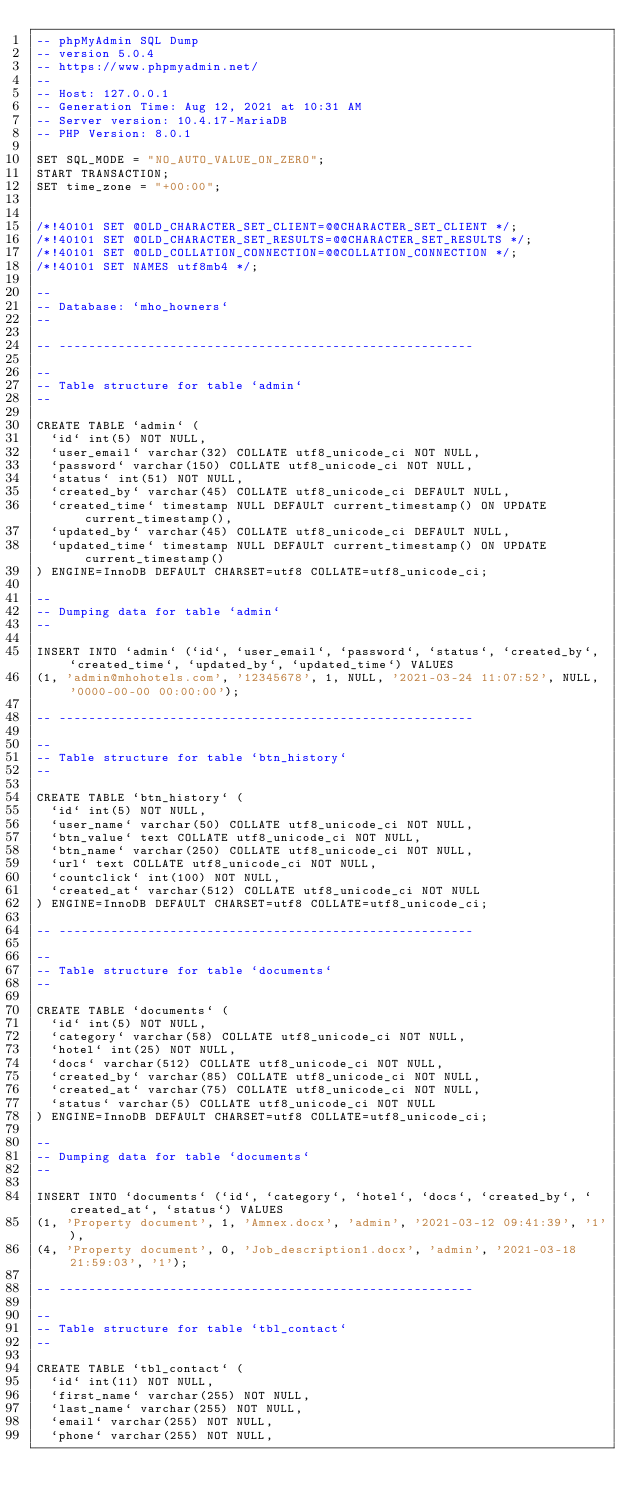Convert code to text. <code><loc_0><loc_0><loc_500><loc_500><_SQL_>-- phpMyAdmin SQL Dump
-- version 5.0.4
-- https://www.phpmyadmin.net/
--
-- Host: 127.0.0.1
-- Generation Time: Aug 12, 2021 at 10:31 AM
-- Server version: 10.4.17-MariaDB
-- PHP Version: 8.0.1

SET SQL_MODE = "NO_AUTO_VALUE_ON_ZERO";
START TRANSACTION;
SET time_zone = "+00:00";


/*!40101 SET @OLD_CHARACTER_SET_CLIENT=@@CHARACTER_SET_CLIENT */;
/*!40101 SET @OLD_CHARACTER_SET_RESULTS=@@CHARACTER_SET_RESULTS */;
/*!40101 SET @OLD_COLLATION_CONNECTION=@@COLLATION_CONNECTION */;
/*!40101 SET NAMES utf8mb4 */;

--
-- Database: `mho_howners`
--

-- --------------------------------------------------------

--
-- Table structure for table `admin`
--

CREATE TABLE `admin` (
  `id` int(5) NOT NULL,
  `user_email` varchar(32) COLLATE utf8_unicode_ci NOT NULL,
  `password` varchar(150) COLLATE utf8_unicode_ci NOT NULL,
  `status` int(51) NOT NULL,
  `created_by` varchar(45) COLLATE utf8_unicode_ci DEFAULT NULL,
  `created_time` timestamp NULL DEFAULT current_timestamp() ON UPDATE current_timestamp(),
  `updated_by` varchar(45) COLLATE utf8_unicode_ci DEFAULT NULL,
  `updated_time` timestamp NULL DEFAULT current_timestamp() ON UPDATE current_timestamp()
) ENGINE=InnoDB DEFAULT CHARSET=utf8 COLLATE=utf8_unicode_ci;

--
-- Dumping data for table `admin`
--

INSERT INTO `admin` (`id`, `user_email`, `password`, `status`, `created_by`, `created_time`, `updated_by`, `updated_time`) VALUES
(1, 'admin@mhohotels.com', '12345678', 1, NULL, '2021-03-24 11:07:52', NULL, '0000-00-00 00:00:00');

-- --------------------------------------------------------

--
-- Table structure for table `btn_history`
--

CREATE TABLE `btn_history` (
  `id` int(5) NOT NULL,
  `user_name` varchar(50) COLLATE utf8_unicode_ci NOT NULL,
  `btn_value` text COLLATE utf8_unicode_ci NOT NULL,
  `btn_name` varchar(250) COLLATE utf8_unicode_ci NOT NULL,
  `url` text COLLATE utf8_unicode_ci NOT NULL,
  `countclick` int(100) NOT NULL,
  `created_at` varchar(512) COLLATE utf8_unicode_ci NOT NULL
) ENGINE=InnoDB DEFAULT CHARSET=utf8 COLLATE=utf8_unicode_ci;

-- --------------------------------------------------------

--
-- Table structure for table `documents`
--

CREATE TABLE `documents` (
  `id` int(5) NOT NULL,
  `category` varchar(58) COLLATE utf8_unicode_ci NOT NULL,
  `hotel` int(25) NOT NULL,
  `docs` varchar(512) COLLATE utf8_unicode_ci NOT NULL,
  `created_by` varchar(85) COLLATE utf8_unicode_ci NOT NULL,
  `created_at` varchar(75) COLLATE utf8_unicode_ci NOT NULL,
  `status` varchar(5) COLLATE utf8_unicode_ci NOT NULL
) ENGINE=InnoDB DEFAULT CHARSET=utf8 COLLATE=utf8_unicode_ci;

--
-- Dumping data for table `documents`
--

INSERT INTO `documents` (`id`, `category`, `hotel`, `docs`, `created_by`, `created_at`, `status`) VALUES
(1, 'Property document', 1, 'Amnex.docx', 'admin', '2021-03-12 09:41:39', '1'),
(4, 'Property document', 0, 'Job_description1.docx', 'admin', '2021-03-18 21:59:03', '1');

-- --------------------------------------------------------

--
-- Table structure for table `tbl_contact`
--

CREATE TABLE `tbl_contact` (
  `id` int(11) NOT NULL,
  `first_name` varchar(255) NOT NULL,
  `last_name` varchar(255) NOT NULL,
  `email` varchar(255) NOT NULL,
  `phone` varchar(255) NOT NULL,</code> 